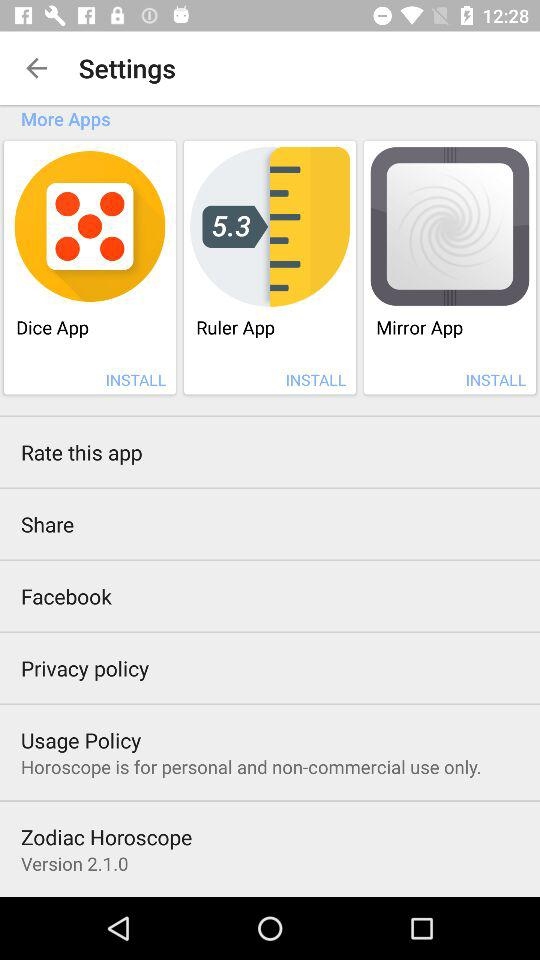What is the name of the application? The names of the applications are "Zodiac Horoscope", "Dice App", "Ruler App" and "Mirror App". 